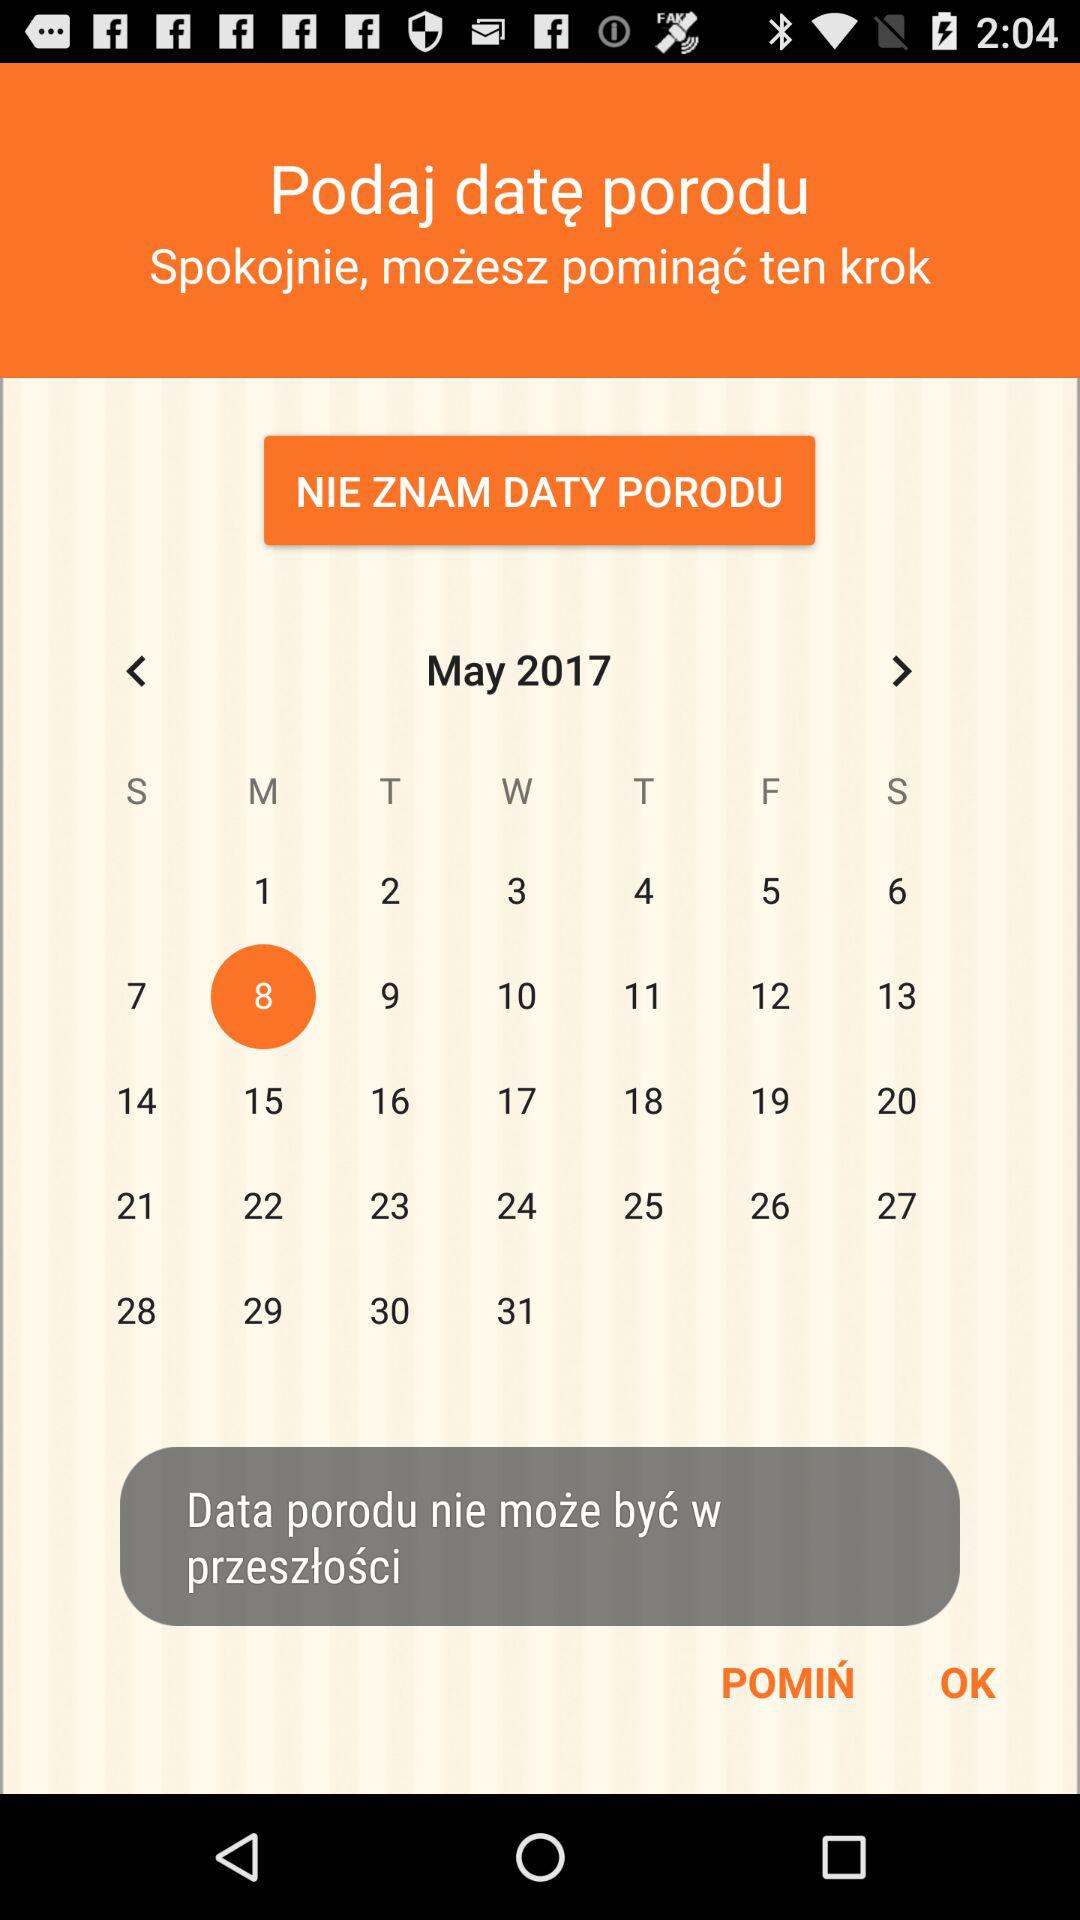How many months are available to select?
Answer the question using a single word or phrase. 12 